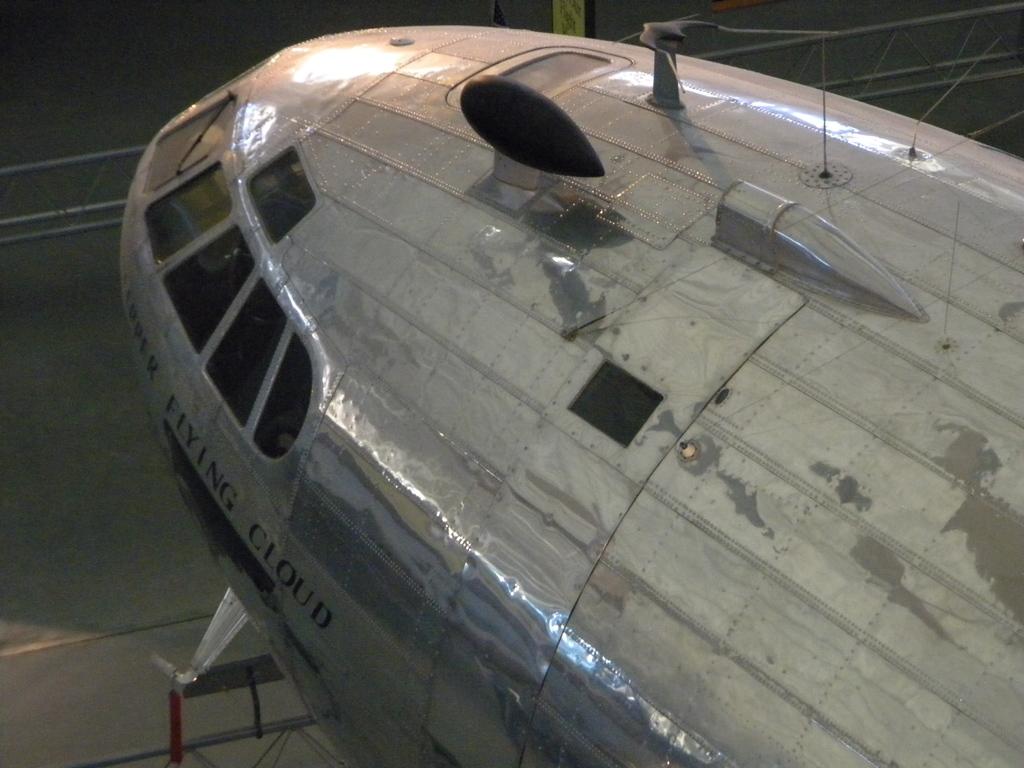What type of cloud is mentioned on the plane?
Give a very brief answer. Flying. 